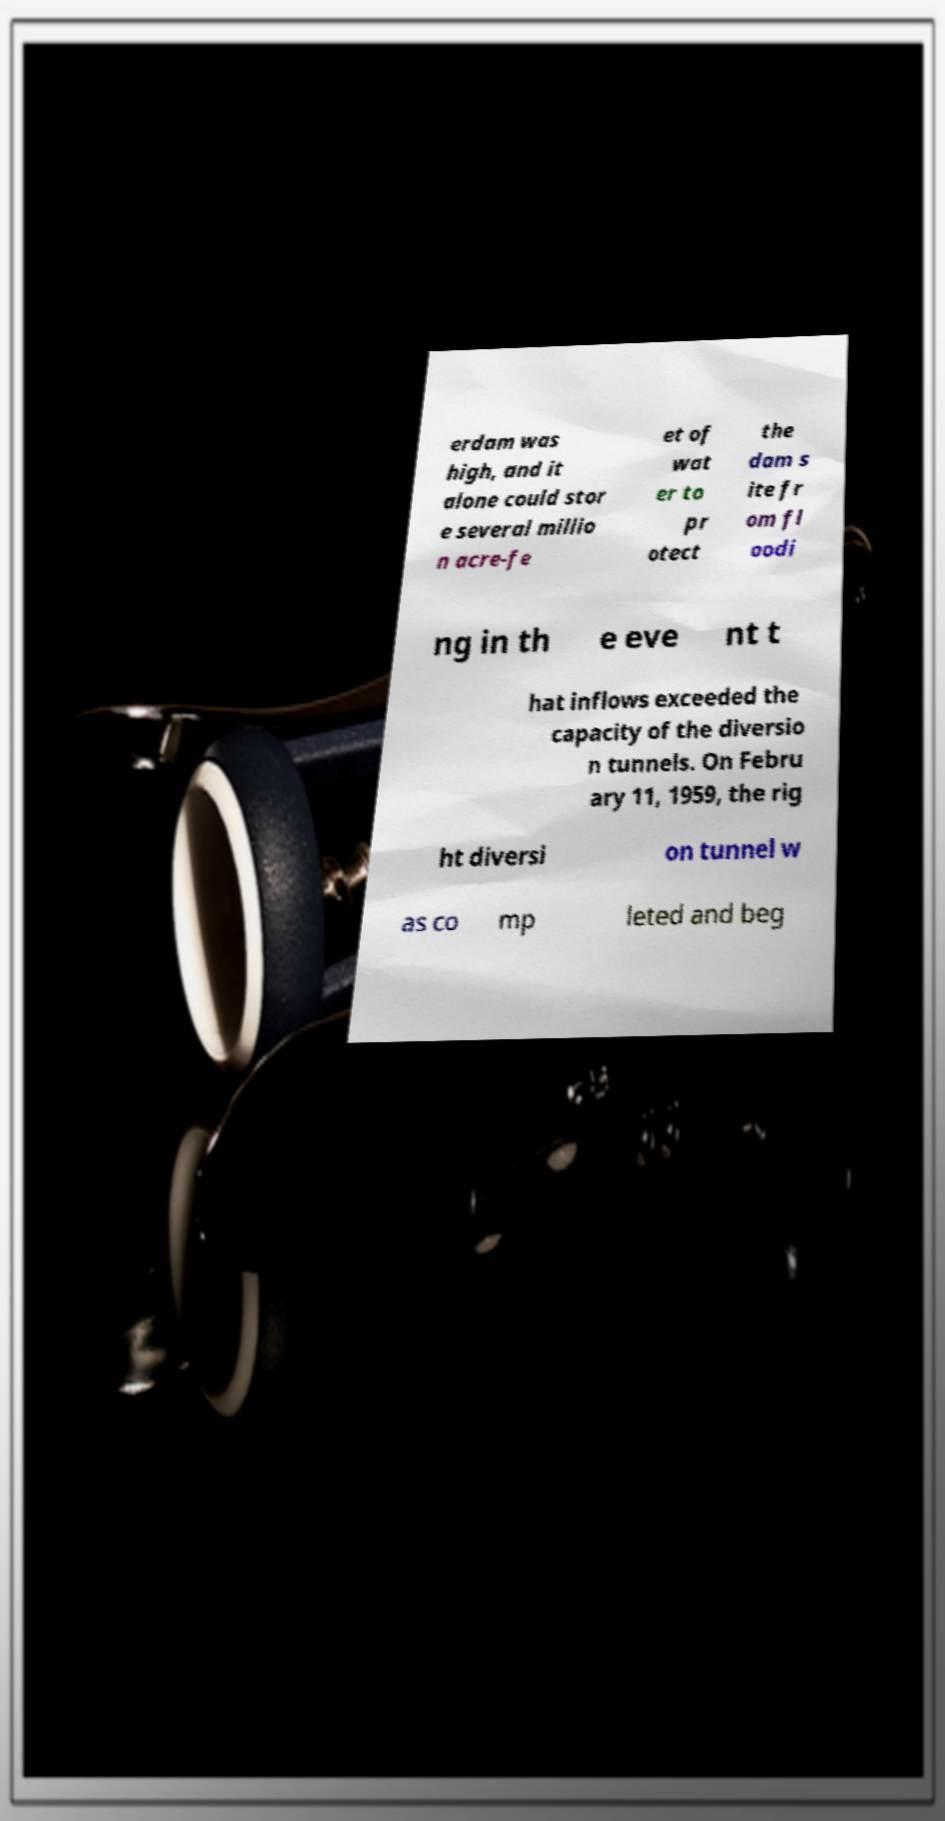Please identify and transcribe the text found in this image. erdam was high, and it alone could stor e several millio n acre-fe et of wat er to pr otect the dam s ite fr om fl oodi ng in th e eve nt t hat inflows exceeded the capacity of the diversio n tunnels. On Febru ary 11, 1959, the rig ht diversi on tunnel w as co mp leted and beg 